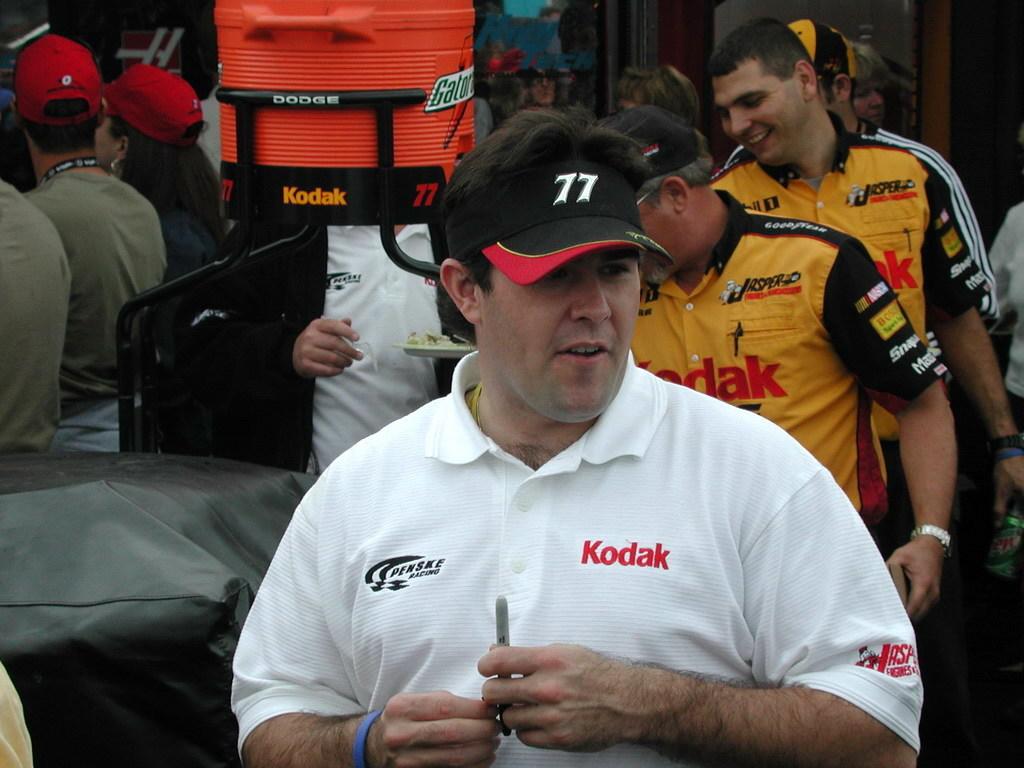Is penske on the right side of his shirt?
Provide a short and direct response. Yes. 